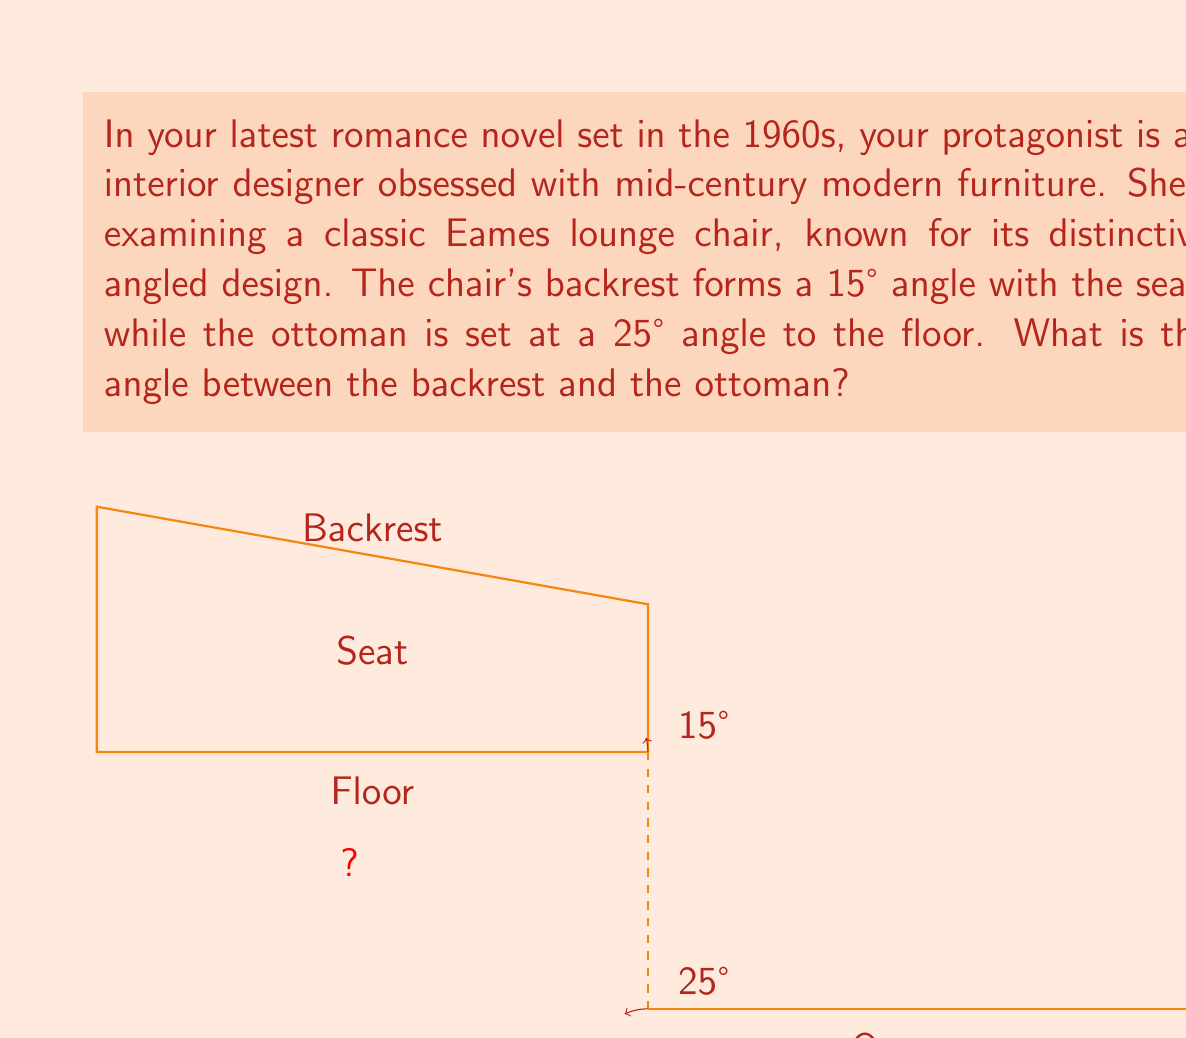Can you solve this math problem? To solve this problem, we need to follow these steps:

1) First, let's understand what we're given:
   - The backrest forms a 15° angle with the seat
   - The ottoman forms a 25° angle with the floor

2) We need to find the angle between the backrest and the ottoman. This is equivalent to finding the sum of:
   a) The angle between the backrest and the floor
   b) The angle between the ottoman and the floor

3) To find the angle between the backrest and the floor:
   - The backrest is at 15° to the seat
   - The seat is parallel to the floor
   - Therefore, the backrest is also at 15° to the floor

4) We already know the ottoman is at 25° to the floor

5) Now we can calculate the total angle:
   $$ \text{Total Angle} = \text{Backrest to Floor} + \text{Ottoman to Floor} $$
   $$ \text{Total Angle} = 15° + 25° = 40° $$

Thus, the angle between the backrest and the ottoman is 40°.
Answer: 40° 